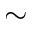<formula> <loc_0><loc_0><loc_500><loc_500>\sim</formula> 